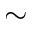<formula> <loc_0><loc_0><loc_500><loc_500>\sim</formula> 